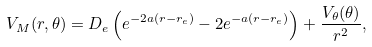<formula> <loc_0><loc_0><loc_500><loc_500>V _ { M } ( r , \theta ) = D _ { e } \left ( e ^ { - 2 a ( r - r _ { e } ) } - 2 e ^ { - a ( r - r _ { e } ) } \right ) + \frac { V _ { \theta } ( \theta ) } { r ^ { 2 } } ,</formula> 